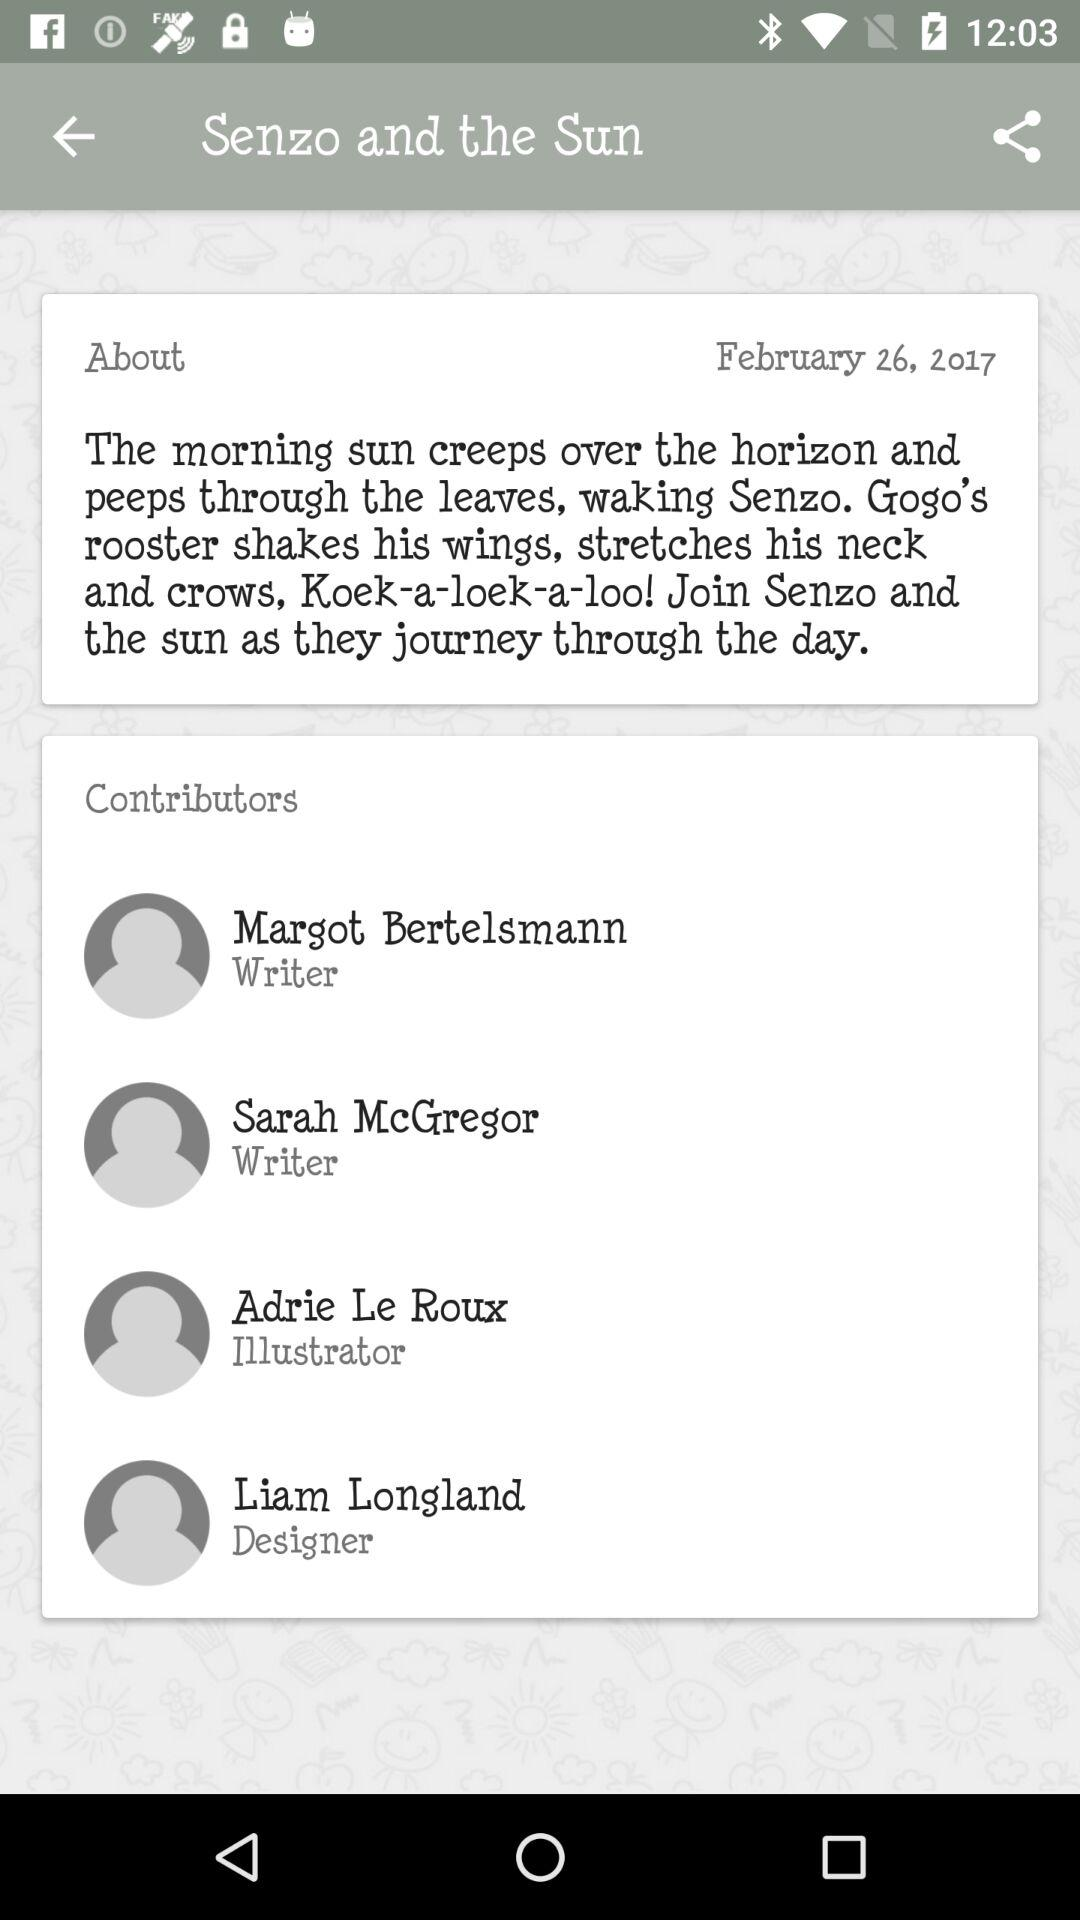Who is the designer? The designer is Liam Longland. 